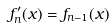Convert formula to latex. <formula><loc_0><loc_0><loc_500><loc_500>f _ { n } ^ { \prime } ( x ) = f _ { n - 1 } ( x )</formula> 